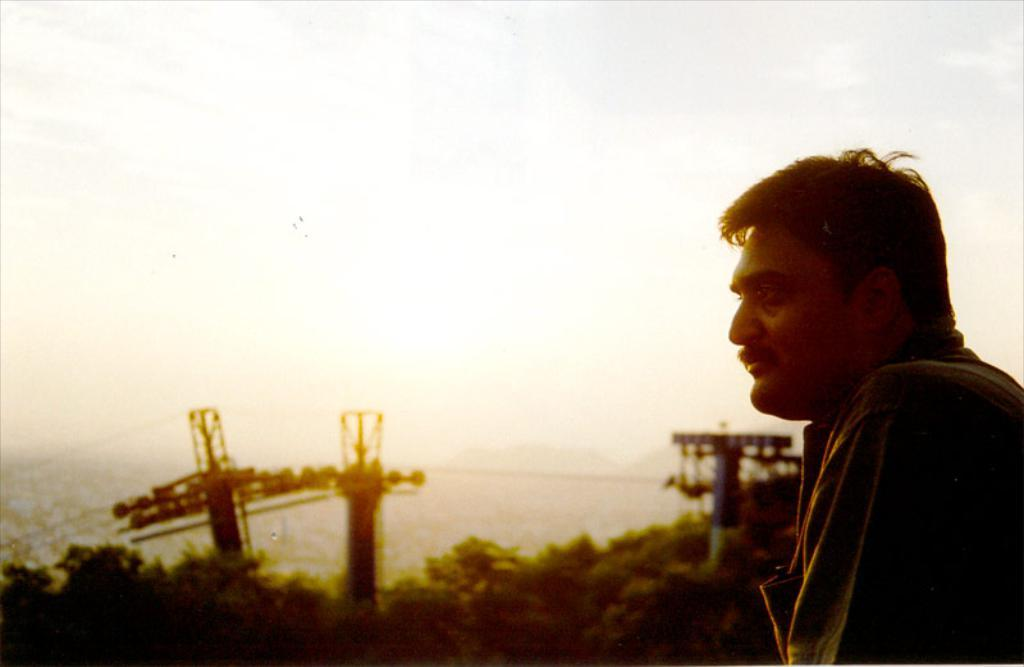What is located on the left side of the image? There is a person standing on the left side of the image. What can be seen in the background of the image? The sky, clouds, trees, pole-type structures, wires, and a few other objects are visible in the background of the image. Can you describe the sky in the image? The sky is visible in the background of the image. Can you tell me how many giraffes are present in the image? There are no giraffes present in the image. What type of event is taking place in the image? There is no indication of an event taking place in the image. 